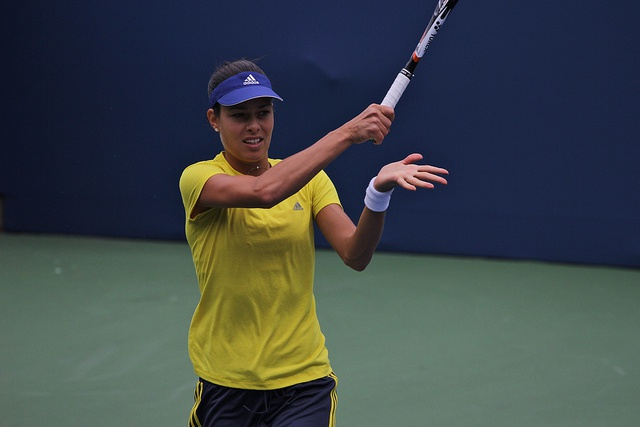Describe the objects in this image and their specific colors. I can see people in black, olive, and brown tones and tennis racket in black, navy, darkgray, and lavender tones in this image. 